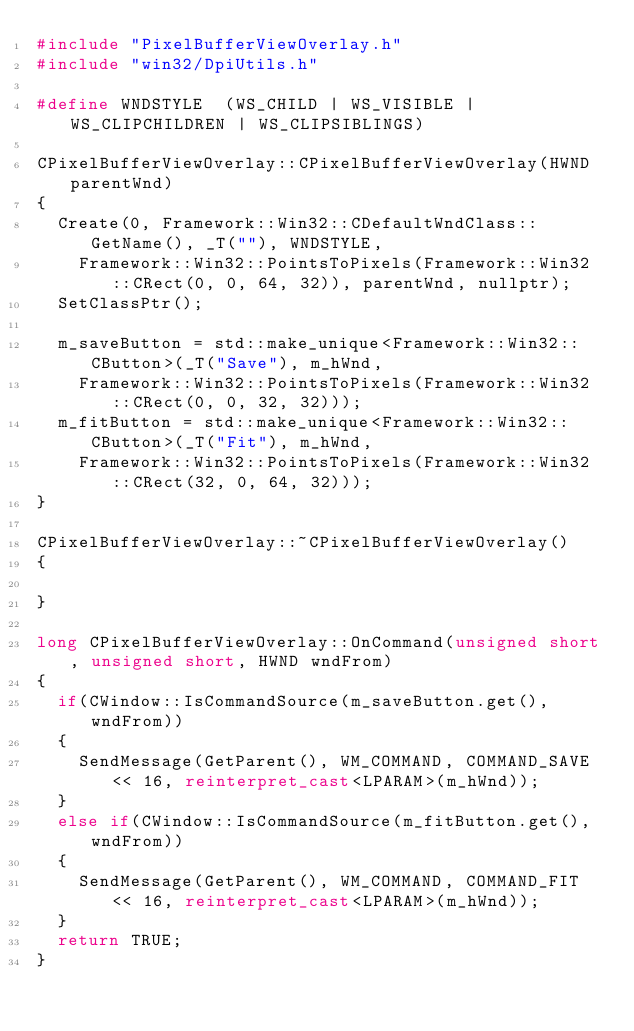Convert code to text. <code><loc_0><loc_0><loc_500><loc_500><_C++_>#include "PixelBufferViewOverlay.h"
#include "win32/DpiUtils.h"

#define WNDSTYLE	(WS_CHILD | WS_VISIBLE | WS_CLIPCHILDREN | WS_CLIPSIBLINGS)

CPixelBufferViewOverlay::CPixelBufferViewOverlay(HWND parentWnd)
{
	Create(0, Framework::Win32::CDefaultWndClass::GetName(), _T(""), WNDSTYLE, 
		Framework::Win32::PointsToPixels(Framework::Win32::CRect(0, 0, 64, 32)), parentWnd, nullptr);
	SetClassPtr();

	m_saveButton = std::make_unique<Framework::Win32::CButton>(_T("Save"), m_hWnd, 
		Framework::Win32::PointsToPixels(Framework::Win32::CRect(0, 0, 32, 32)));
	m_fitButton = std::make_unique<Framework::Win32::CButton>(_T("Fit"), m_hWnd, 
		Framework::Win32::PointsToPixels(Framework::Win32::CRect(32, 0, 64, 32)));
}

CPixelBufferViewOverlay::~CPixelBufferViewOverlay()
{

}

long CPixelBufferViewOverlay::OnCommand(unsigned short, unsigned short, HWND wndFrom)
{
	if(CWindow::IsCommandSource(m_saveButton.get(), wndFrom))
	{
		SendMessage(GetParent(), WM_COMMAND, COMMAND_SAVE << 16, reinterpret_cast<LPARAM>(m_hWnd));
	}
	else if(CWindow::IsCommandSource(m_fitButton.get(), wndFrom))
	{
		SendMessage(GetParent(), WM_COMMAND, COMMAND_FIT << 16, reinterpret_cast<LPARAM>(m_hWnd));
	}
	return TRUE;
}
</code> 